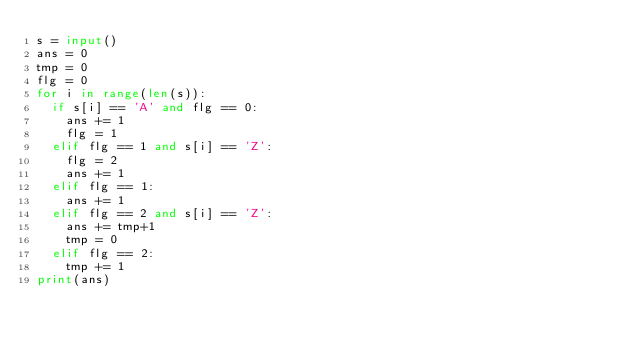<code> <loc_0><loc_0><loc_500><loc_500><_Python_>s = input()
ans = 0
tmp = 0
flg = 0
for i in range(len(s)):
  if s[i] == 'A' and flg == 0:
    ans += 1
    flg = 1
  elif flg == 1 and s[i] == 'Z':
    flg = 2
    ans += 1
  elif flg == 1:
    ans += 1
  elif flg == 2 and s[i] == 'Z':
    ans += tmp+1
    tmp = 0
  elif flg == 2:
    tmp += 1
print(ans)</code> 